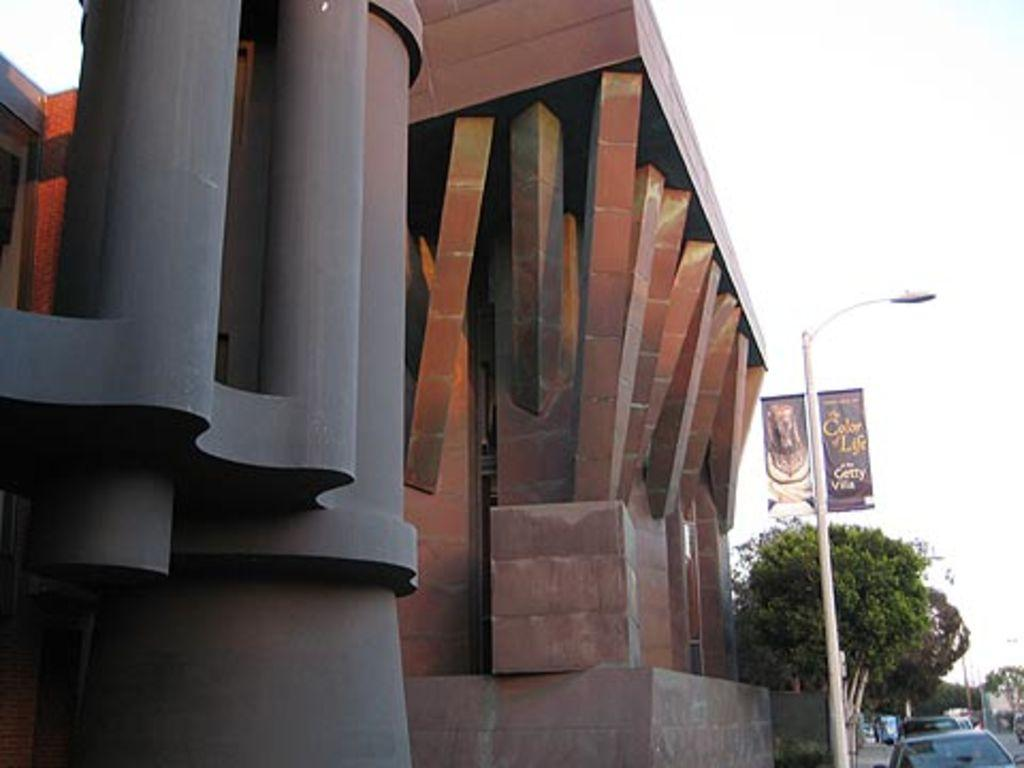What type of structure is visible in the image? There is a building in the image. What other natural elements can be seen in the image? There are trees in the image. What type of vehicles are present on the road in the image? There are cars on the road in the image. What type of lighting is present in the image? There are pole lights in the image. What type of signage is present in the image? There are banners with text in the image. How would you describe the weather based on the image? The sky is cloudy in the image. What color of paint is being used to create the liquid effect on the banners in the image? There is no liquid effect or paint mentioned in the image; it only features banners with text. 